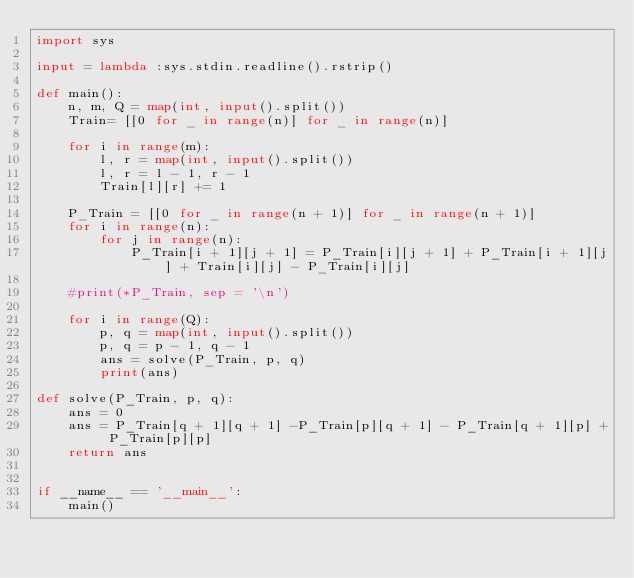Convert code to text. <code><loc_0><loc_0><loc_500><loc_500><_Python_>import sys

input = lambda :sys.stdin.readline().rstrip()

def main():
    n, m, Q = map(int, input().split())
    Train= [[0 for _ in range(n)] for _ in range(n)]
    
    for i in range(m):
        l, r = map(int, input().split())
        l, r = l - 1, r - 1
        Train[l][r] += 1
    
    P_Train = [[0 for _ in range(n + 1)] for _ in range(n + 1)]
    for i in range(n):
        for j in range(n):
            P_Train[i + 1][j + 1] = P_Train[i][j + 1] + P_Train[i + 1][j] + Train[i][j] - P_Train[i][j]
    
    #print(*P_Train, sep = '\n')

    for i in range(Q):
        p, q = map(int, input().split())
        p, q = p - 1, q - 1
        ans = solve(P_Train, p, q)
        print(ans)

def solve(P_Train, p, q):
    ans = 0
    ans = P_Train[q + 1][q + 1] -P_Train[p][q + 1] - P_Train[q + 1][p] + P_Train[p][p]
    return ans


if __name__ == '__main__':
    main()</code> 